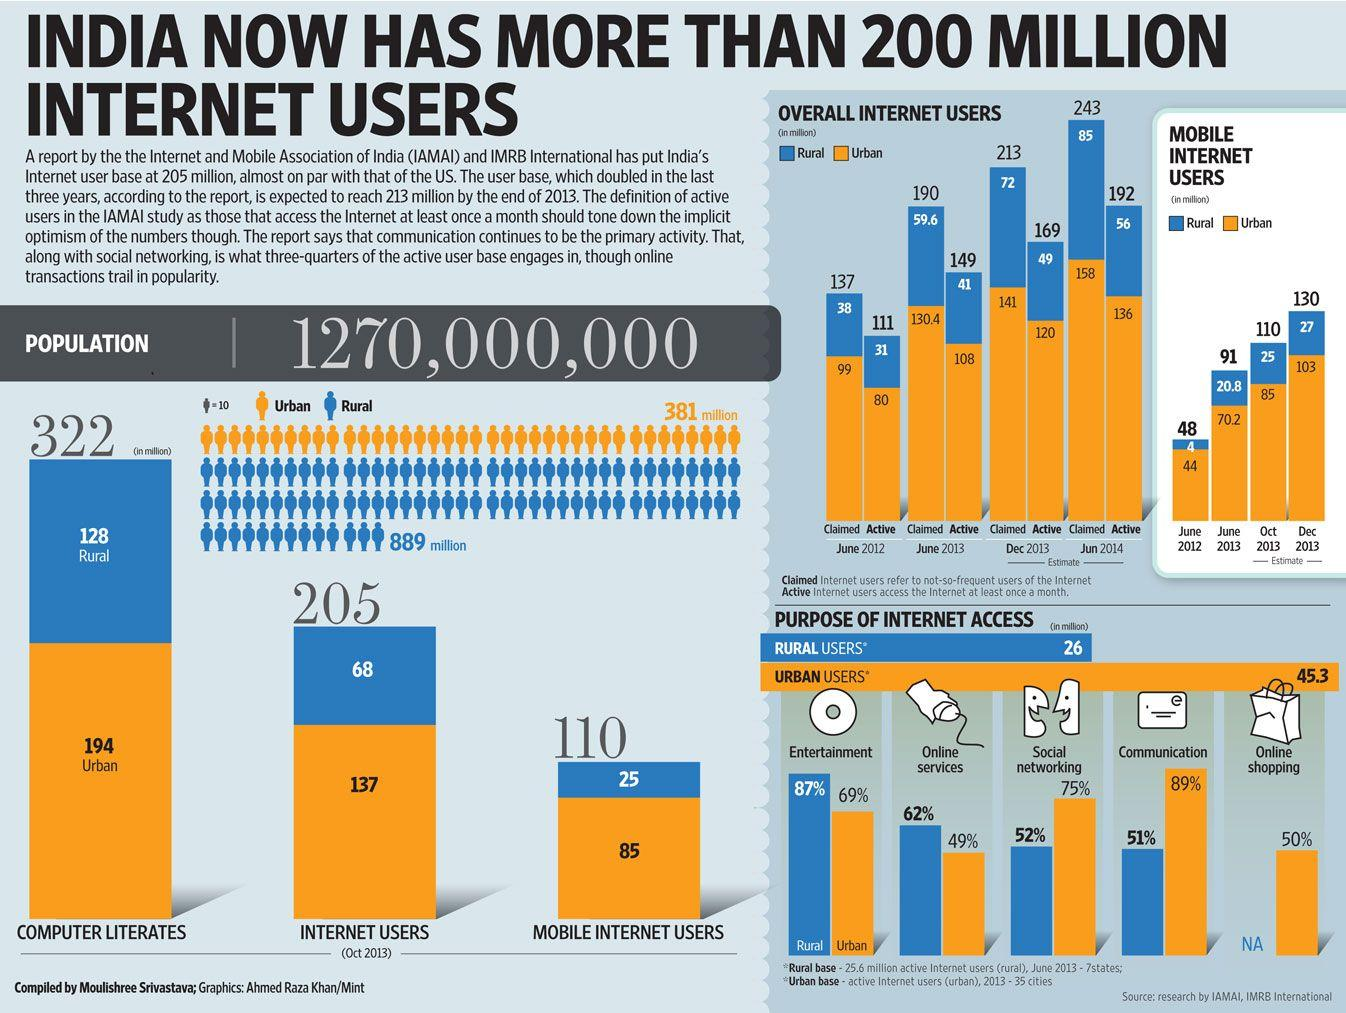Identify some key points in this picture. According to recent statistics, 62% of rural users in India have access to the internet for online services. According to an estimate, there were approximately 56 million active internet users in rural areas of India in June 2014. In June 2013, the estimate of mobile internet users in rural areas of India was 20.8 million. In India, approximately 50% of urban users engage in online shopping. As of December 2013, it is estimated that there were approximately 103 million mobile internet users in urban areas of India. 